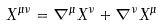Convert formula to latex. <formula><loc_0><loc_0><loc_500><loc_500>X ^ { \mu \nu } = \nabla ^ { \mu } X ^ { \nu } + \nabla ^ { \nu } X ^ { \mu }</formula> 